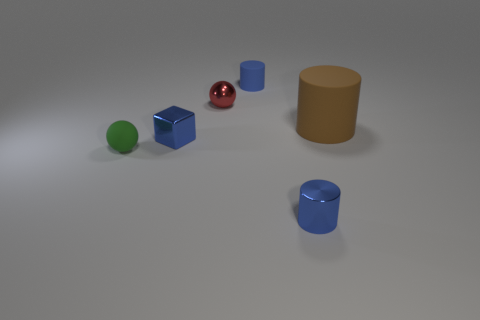Add 4 green rubber objects. How many objects exist? 10 Subtract all balls. How many objects are left? 4 Subtract 0 purple cylinders. How many objects are left? 6 Subtract all red shiny spheres. Subtract all tiny blue cubes. How many objects are left? 4 Add 4 large things. How many large things are left? 5 Add 2 blue things. How many blue things exist? 5 